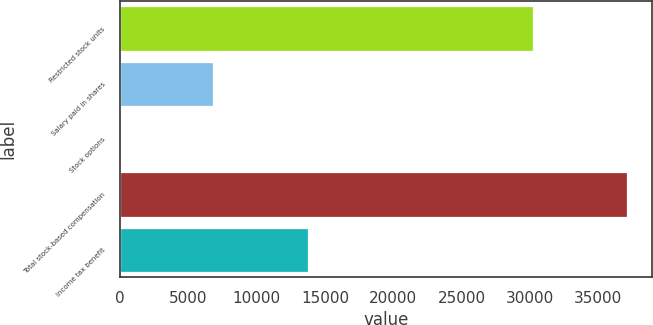Convert chart. <chart><loc_0><loc_0><loc_500><loc_500><bar_chart><fcel>Restricted stock units<fcel>Salary paid in shares<fcel>Stock options<fcel>Total stock-based compensation<fcel>Income tax benefit<nl><fcel>30245<fcel>6820<fcel>16<fcel>37081<fcel>13762<nl></chart> 